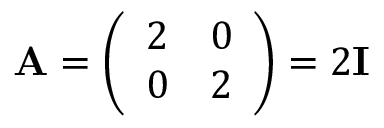Convert formula to latex. <formula><loc_0><loc_0><loc_500><loc_500>A = { \left ( \begin{array} { l l } { 2 } & { 0 } \\ { 0 } & { 2 } \end{array} \right ) } = 2 I</formula> 